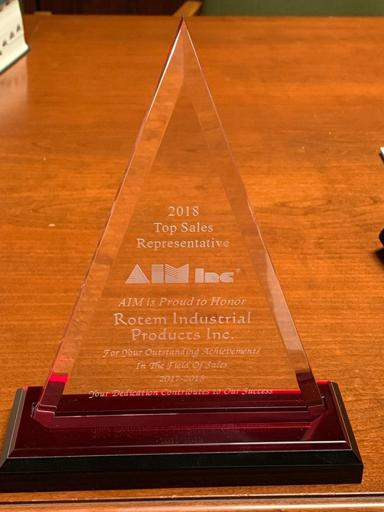Can you tell me more about what AIM represents and why this award may be significant? AIM, the Association for Automatic Identification and Mobility, is an industry group that advocates for the usage and standards of automatic identification and data capture technologies. An award from such an organization would be significant because it reflects the recipients' leadership and innovation in technologies that improve efficiency, accuracy, and networking in business processes. How might receiving this award benefit Rotem Industrial Products Inc.? Being recognized as a top sales representative by AIM would not only enhance Rotem Industrial Products Inc.'s reputation within the industry, but it could also foster trust among potential clients, lead to more business opportunities, and serve as a motivational boost for the company's sales and management teams. 